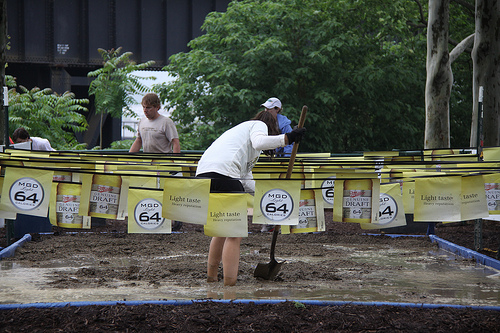<image>
Is there a paper on the wire? Yes. Looking at the image, I can see the paper is positioned on top of the wire, with the wire providing support. 